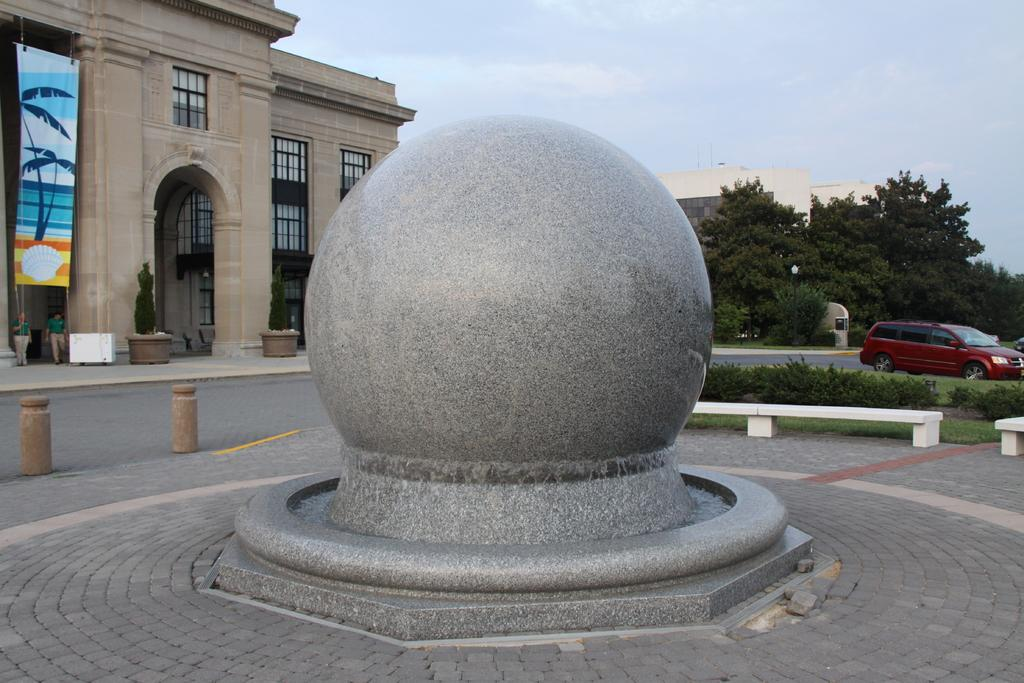What is the main object in the foreground of the image? There is a round stone in the foreground of the image. What can be seen in the background of the image? There are buildings, trees, people, a car, and the sky visible in the background of the image. Can you describe the type of structures in the background? The buildings in the background are likely residential or commercial buildings. What type of weather can be inferred from the image? The sky is visible in the background, but there is no indication of rain, sleet, or any other specific weather condition. What sense is being stimulated by the power of the sleet in the image? There is no sleet present in the image, and therefore no sense is being stimulated by it. 